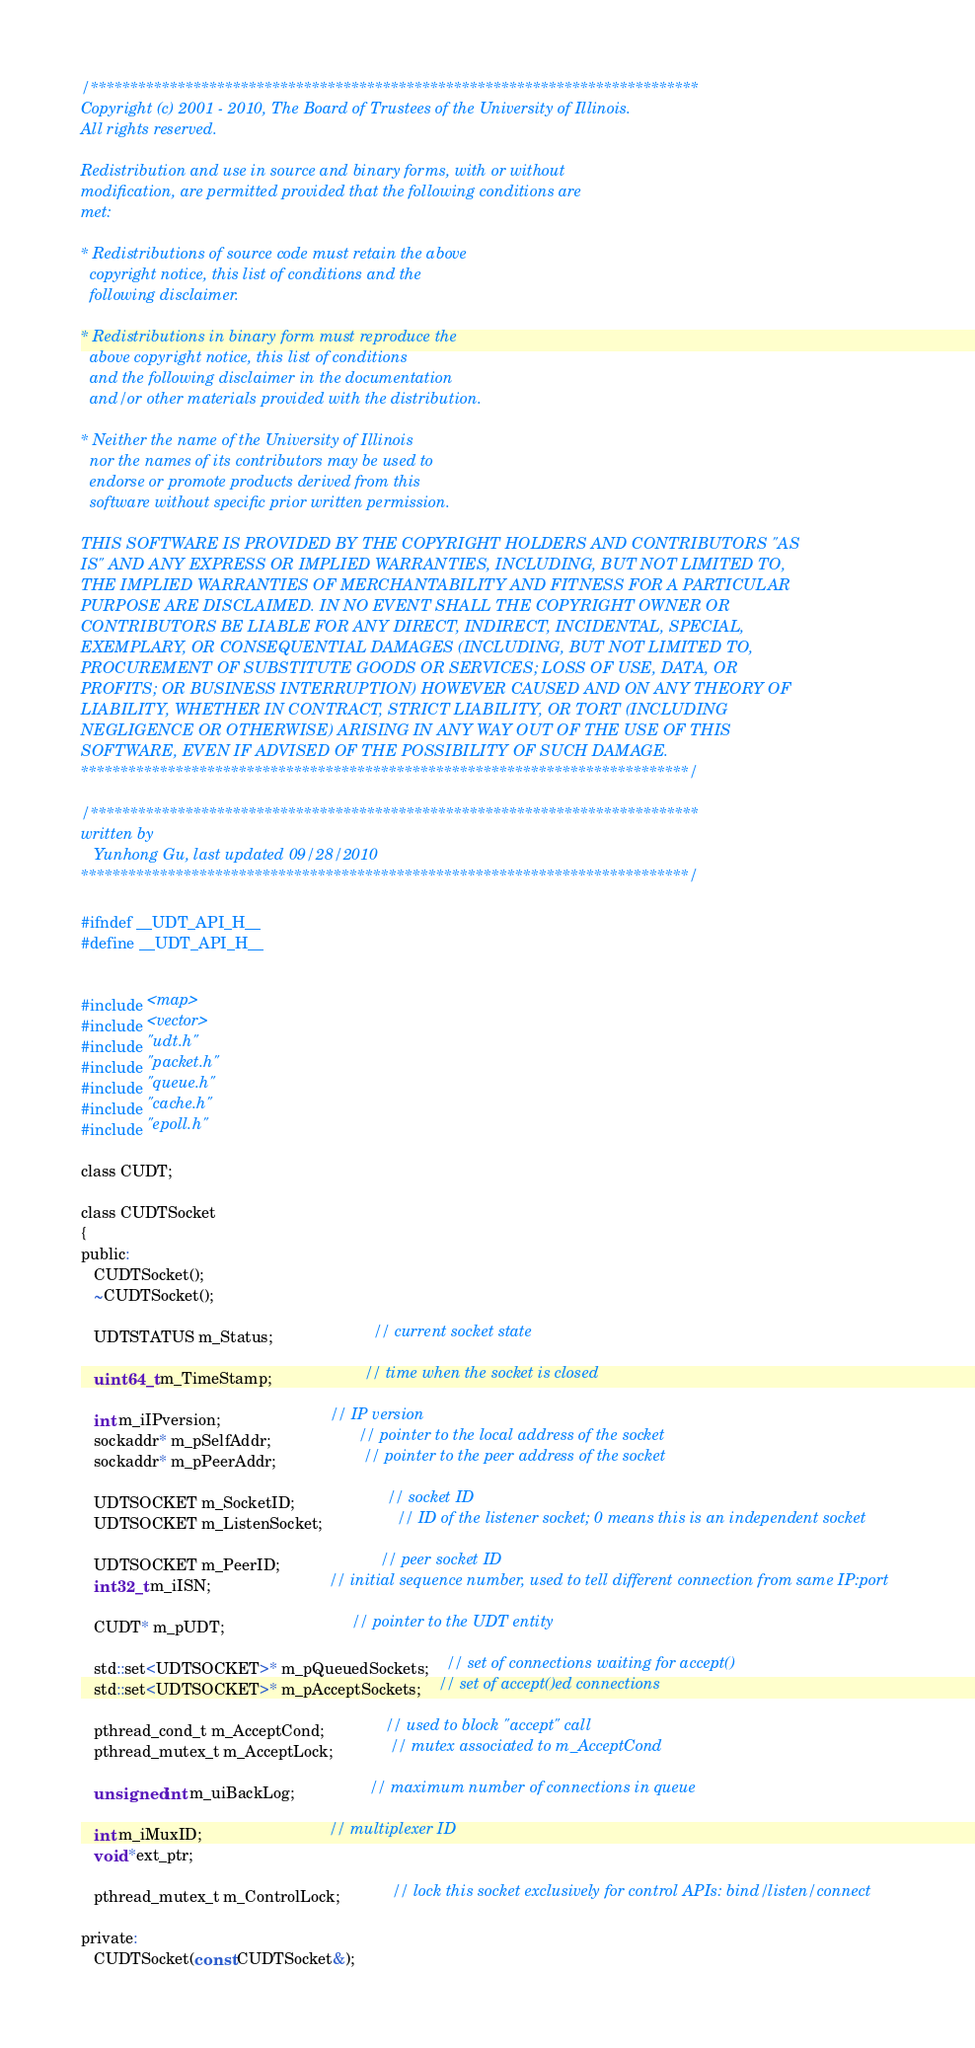<code> <loc_0><loc_0><loc_500><loc_500><_C_>/*****************************************************************************
Copyright (c) 2001 - 2010, The Board of Trustees of the University of Illinois.
All rights reserved.

Redistribution and use in source and binary forms, with or without
modification, are permitted provided that the following conditions are
met:

* Redistributions of source code must retain the above
  copyright notice, this list of conditions and the
  following disclaimer.

* Redistributions in binary form must reproduce the
  above copyright notice, this list of conditions
  and the following disclaimer in the documentation
  and/or other materials provided with the distribution.

* Neither the name of the University of Illinois
  nor the names of its contributors may be used to
  endorse or promote products derived from this
  software without specific prior written permission.

THIS SOFTWARE IS PROVIDED BY THE COPYRIGHT HOLDERS AND CONTRIBUTORS "AS
IS" AND ANY EXPRESS OR IMPLIED WARRANTIES, INCLUDING, BUT NOT LIMITED TO,
THE IMPLIED WARRANTIES OF MERCHANTABILITY AND FITNESS FOR A PARTICULAR
PURPOSE ARE DISCLAIMED. IN NO EVENT SHALL THE COPYRIGHT OWNER OR
CONTRIBUTORS BE LIABLE FOR ANY DIRECT, INDIRECT, INCIDENTAL, SPECIAL,
EXEMPLARY, OR CONSEQUENTIAL DAMAGES (INCLUDING, BUT NOT LIMITED TO,
PROCUREMENT OF SUBSTITUTE GOODS OR SERVICES; LOSS OF USE, DATA, OR
PROFITS; OR BUSINESS INTERRUPTION) HOWEVER CAUSED AND ON ANY THEORY OF
LIABILITY, WHETHER IN CONTRACT, STRICT LIABILITY, OR TORT (INCLUDING
NEGLIGENCE OR OTHERWISE) ARISING IN ANY WAY OUT OF THE USE OF THIS
SOFTWARE, EVEN IF ADVISED OF THE POSSIBILITY OF SUCH DAMAGE.
*****************************************************************************/

/*****************************************************************************
written by
   Yunhong Gu, last updated 09/28/2010
*****************************************************************************/

#ifndef __UDT_API_H__
#define __UDT_API_H__


#include <map>
#include <vector>
#include "udt.h"
#include "packet.h"
#include "queue.h"
#include "cache.h"
#include "epoll.h"

class CUDT;

class CUDTSocket
{
public:
   CUDTSocket();
   ~CUDTSocket();

   UDTSTATUS m_Status;                       // current socket state

   uint64_t m_TimeStamp;                     // time when the socket is closed

   int m_iIPversion;                         // IP version
   sockaddr* m_pSelfAddr;                    // pointer to the local address of the socket
   sockaddr* m_pPeerAddr;                    // pointer to the peer address of the socket

   UDTSOCKET m_SocketID;                     // socket ID
   UDTSOCKET m_ListenSocket;                 // ID of the listener socket; 0 means this is an independent socket

   UDTSOCKET m_PeerID;                       // peer socket ID
   int32_t m_iISN;                           // initial sequence number, used to tell different connection from same IP:port

   CUDT* m_pUDT;                             // pointer to the UDT entity

   std::set<UDTSOCKET>* m_pQueuedSockets;    // set of connections waiting for accept()
   std::set<UDTSOCKET>* m_pAcceptSockets;    // set of accept()ed connections

   pthread_cond_t m_AcceptCond;              // used to block "accept" call
   pthread_mutex_t m_AcceptLock;             // mutex associated to m_AcceptCond

   unsigned int m_uiBackLog;                 // maximum number of connections in queue

   int m_iMuxID;                             // multiplexer ID
   void *ext_ptr;

   pthread_mutex_t m_ControlLock;            // lock this socket exclusively for control APIs: bind/listen/connect

private:
   CUDTSocket(const CUDTSocket&);</code> 